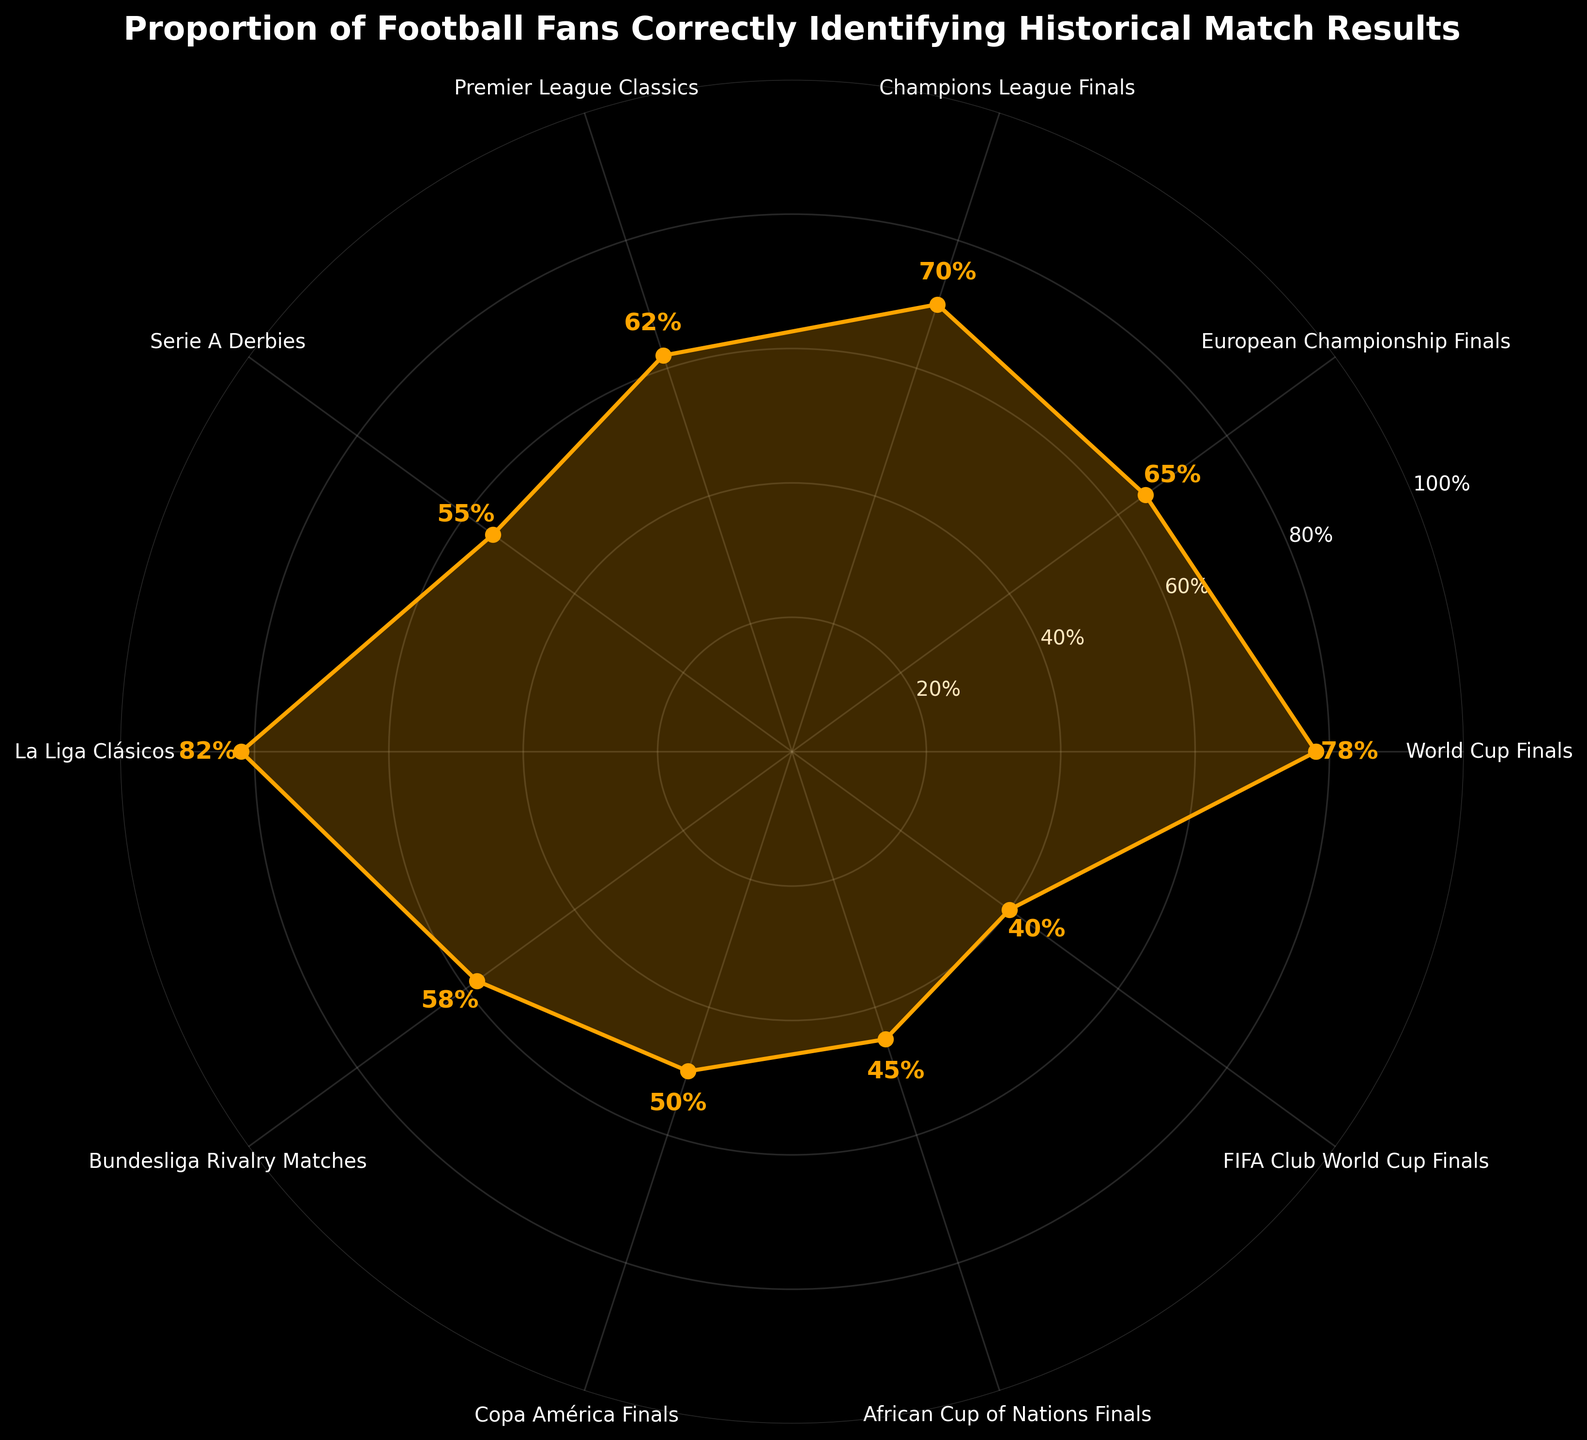what is the percentage of football fans who can correctly identify the results of La Liga Clásicos? The percentage for La Liga Clásicos is directly labeled on the chart.
Answer: 82% which category has the lowest percentage of correctly identified historical match results? Copa América Finals has the lowest percentage at the bottom of the chart, marked with 50%.
Answer: African Cup of Nations Finals which two categories have the closest percentage values? By comparing all the percentages, Champions League Finals (70%) and Premier League Classics (62%) have close values, but Premier League Classics (62%) and Bundesliga Rivalry Matches (58%) are closer.
Answer: Premier League Classics and Bundesliga Rivalry Matches What is the average percentage of fans who correctly identify the European Championship Finals and World Cup Finals? Add the percentages of European Championship Finals (65%) and World Cup Finals (78%), then divide by 2 to find the average: (65 + 78) / 2 = 71.5%.
Answer: 71.5% Which category is identified correctly by more fans, Bundesliga Rivalry Matches or Serie A Derbies? Compare the percentages: Serie A Derbies is 55% and Bundesliga Rivalry Matches is 58%. Since 58% is higher than 55%, more fans identify Bundesliga Rivalry Matches correctly.
Answer: Bundesliga Rivalry Matches How many categories have a percentage above 70%? By checking each category's percentage, World Cup Finals (78%), Champions League Finals (70%), La Liga Clásicos (82%) are above 70%.
Answer: 3 Is the percentage of fans identifying Copa América Finals correctly greater than the percentage of those identifying African Cup of Nations Finals? Copa América Finals has 50% and African Cup of Nations Finals has 45%, so Copa América Finals is greater.
Answer: Yes What is the difference between the highest and lowest percentages? Subtract the lowest percentage (40% for FIFA Club World Cup Finals) from the highest percentage (82% for La Liga Clásicos): 82 - 40 = 42%.
Answer: 42% 